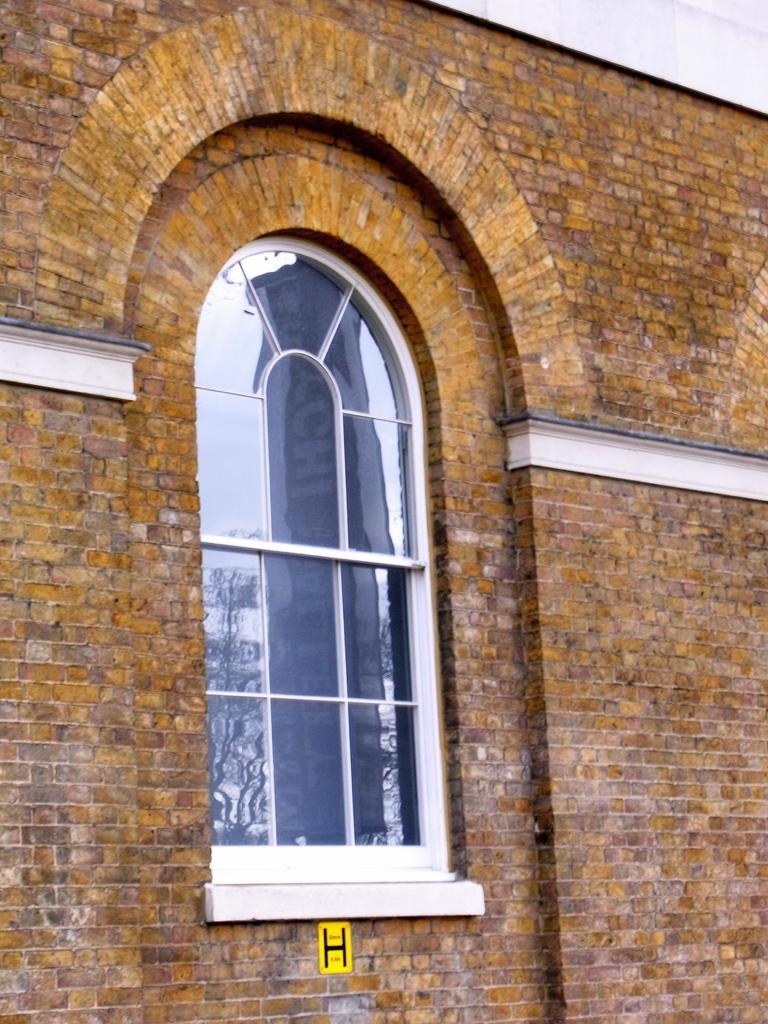Could you give a brief overview of what you see in this image? This picture seems to be clicked outside. In the foreground we can see the wall and the window of the building and we can see the arch and some other items. 